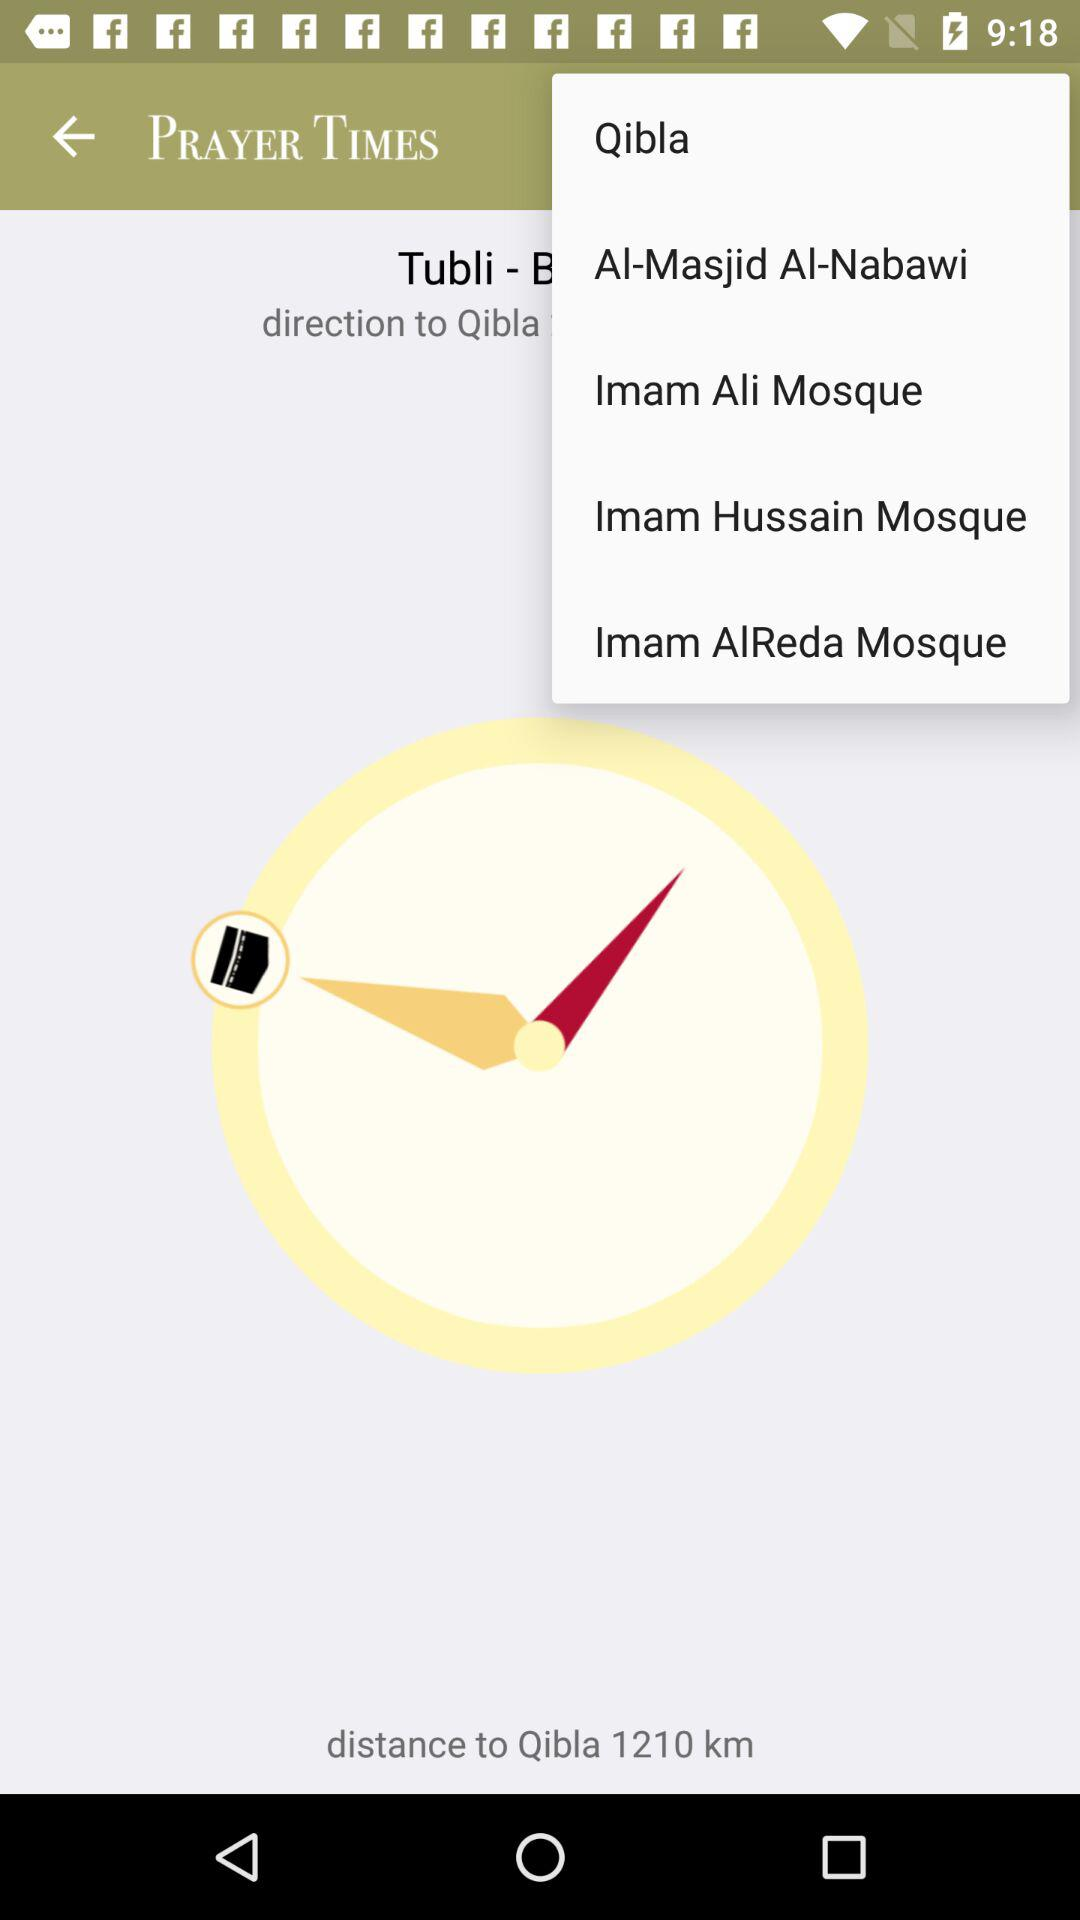How far is Qibla in kilometers? Qibla is 1210 kilometers away. 